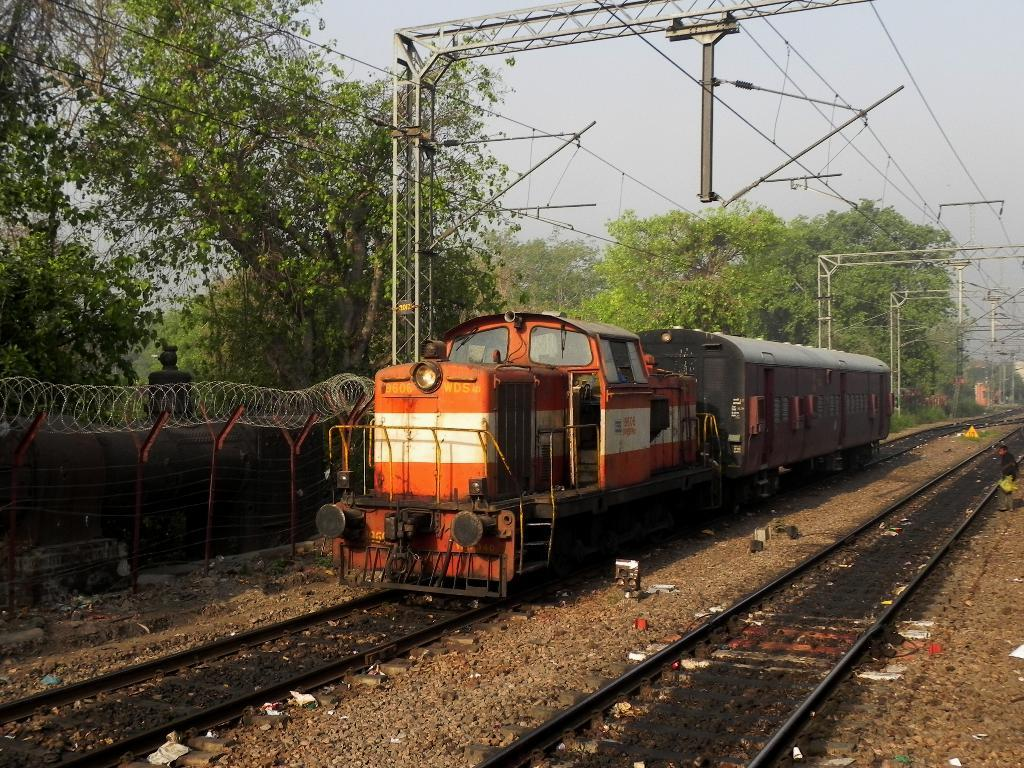What is the main subject of the image? The main subject of the image is a train. What is the train doing in the image? The train is moving on a railway track. Can you describe any other objects or people in the image? There is a person in the image, as well as a fence, poles, trees, wires, and a cloudy sky. What type of sign can be seen on the train in the image? There is no sign visible on the train in the image. Can you tell me how many boots are present in the image? There are no boots present in the image. 